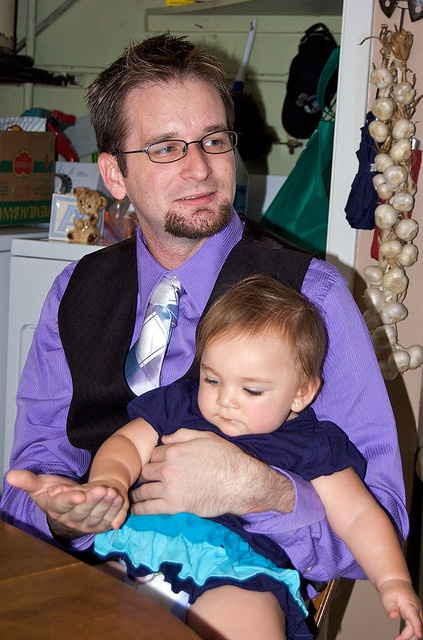Describe the objects in this image and their specific colors. I can see people in gray, black, lightpink, and violet tones, people in gray, tan, navy, black, and brown tones, dining table in gray, maroon, black, and navy tones, and tie in gray, lavender, darkgray, and blue tones in this image. 